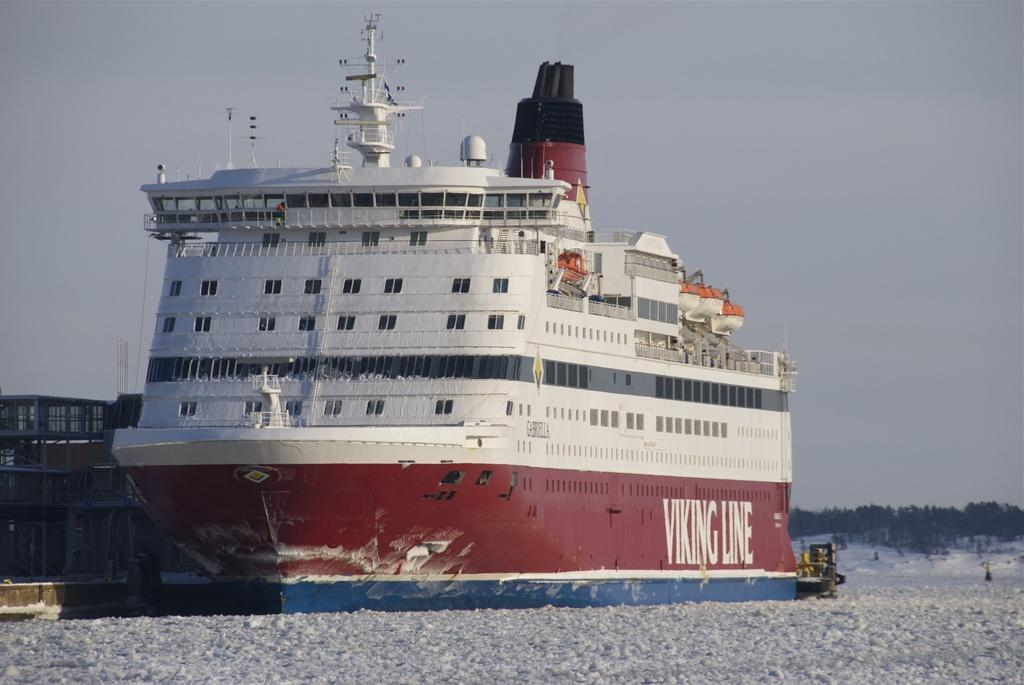What is the main subject of the image? There is a ship in the image. What is the ship situated in? The ship is in water, which is visible in the image. What type of vegetation can be seen in the image? There are trees in the image. What can be seen in the background of the image? The sky is visible in the background of the image. What language is the cook speaking to the neck in the image? There is no cook or neck present in the image, so this question cannot be answered. 